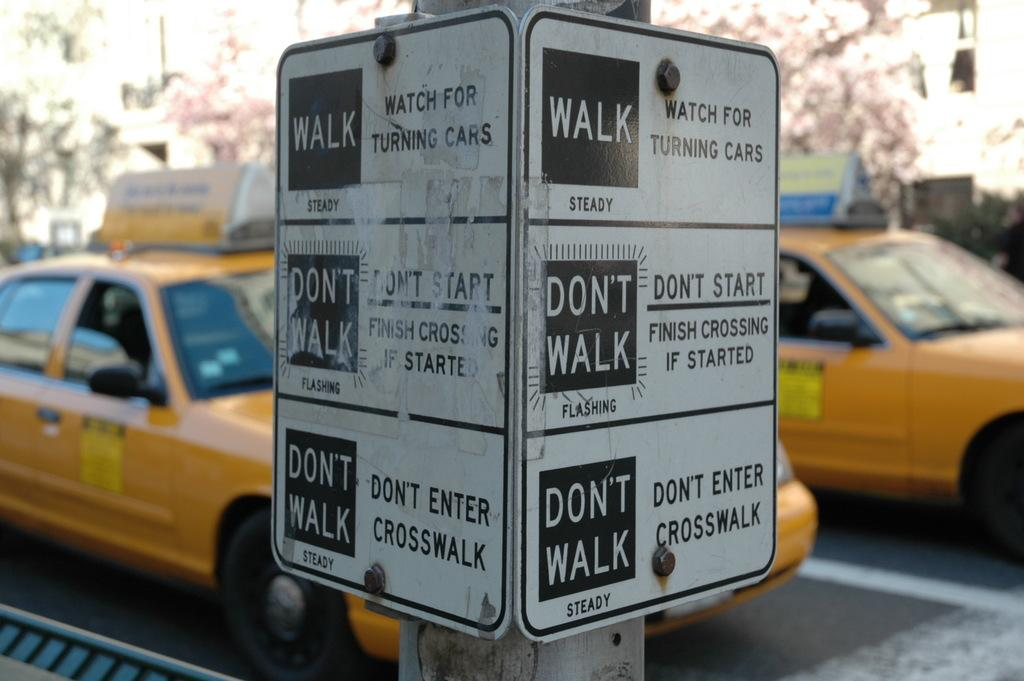<image>
Create a compact narrative representing the image presented. Two taxi cabs in the back at a traffic light with a walking sign on the sidewalk 